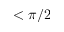<formula> <loc_0><loc_0><loc_500><loc_500>< \pi / 2</formula> 